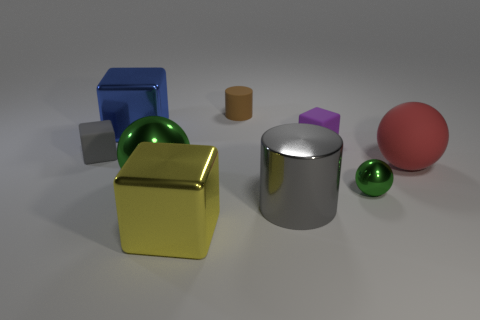Imagine these objects are part of a learning module. What could be the lesson objective? If these objects were part of a learning module, the lesson objective could be understanding 3D shapes and their properties. The module might cover how to identify each shape, describe their characteristics, understand the concept of reflection and material properties such as matte, shiny, or metallic finishes, as well as basic principles of light and shadow in visual perception. 